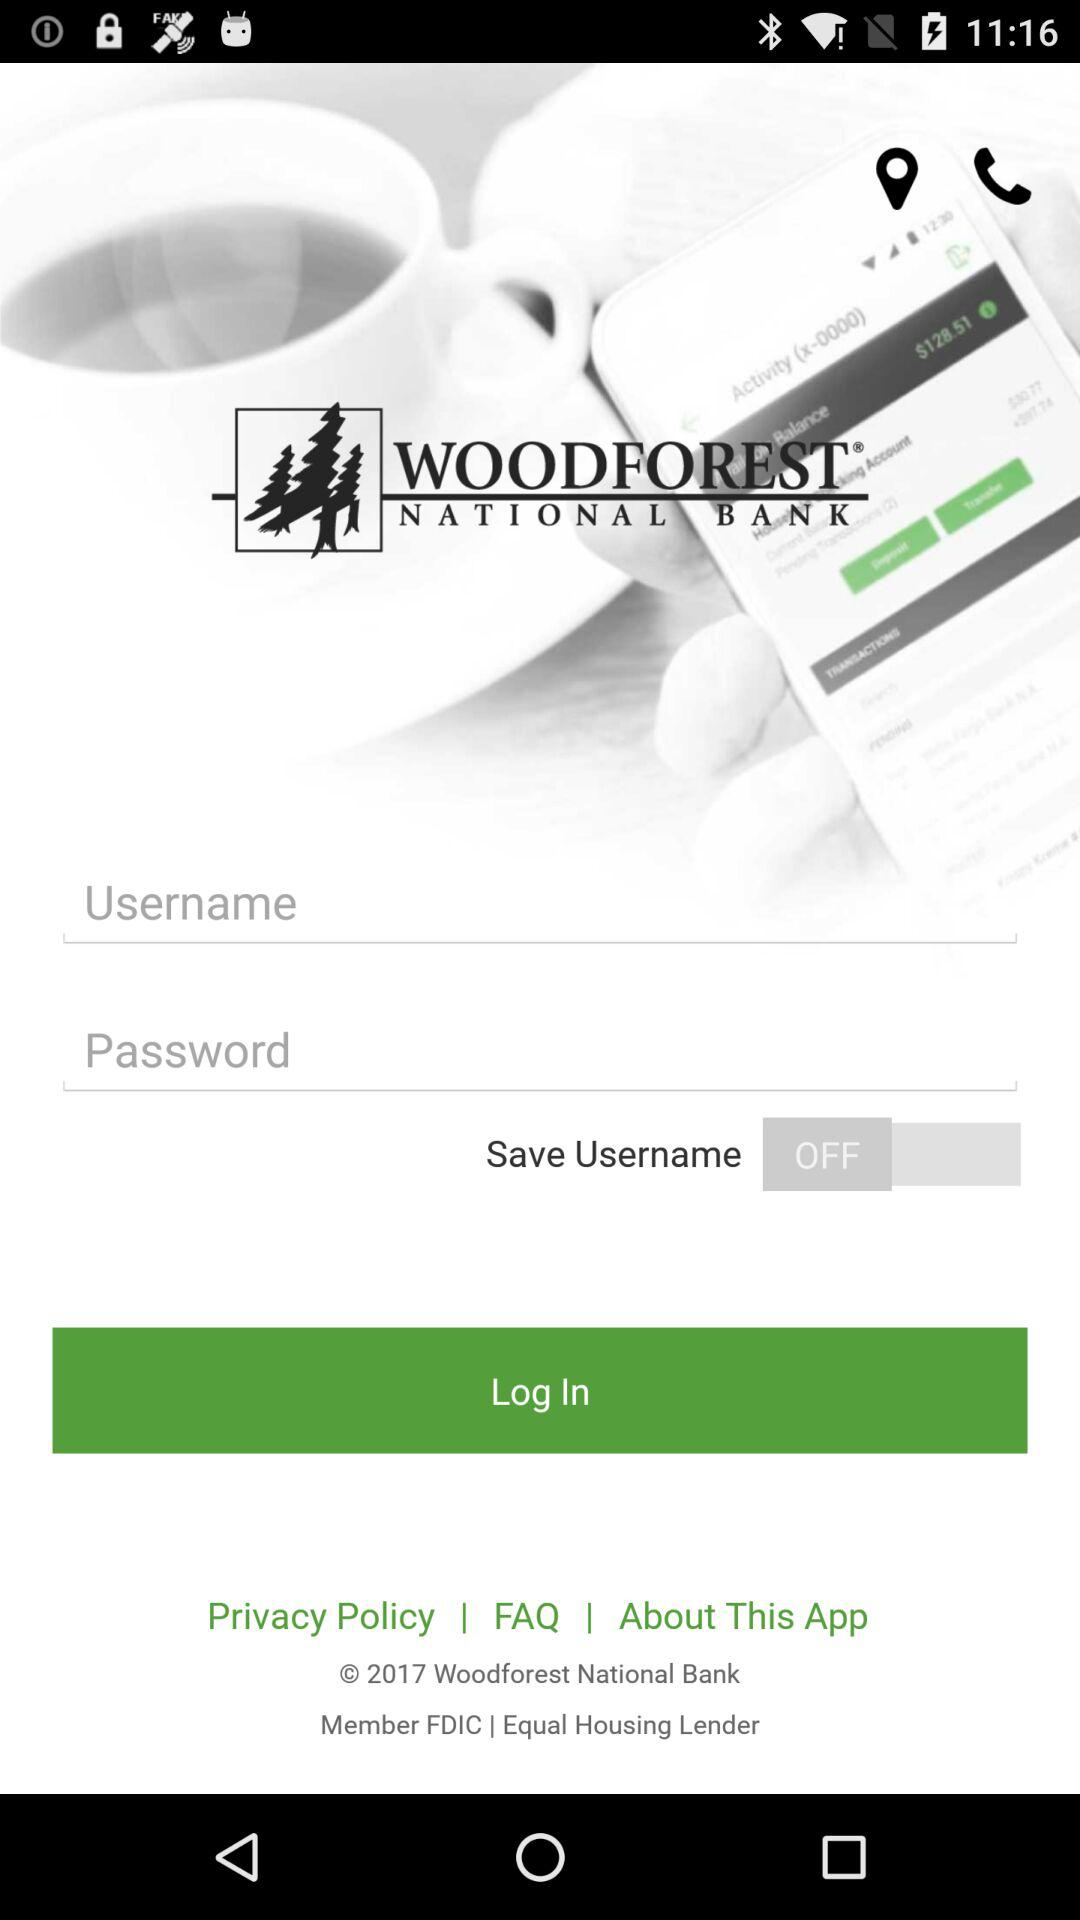What is the copyright year? The copyright year is 2017. 